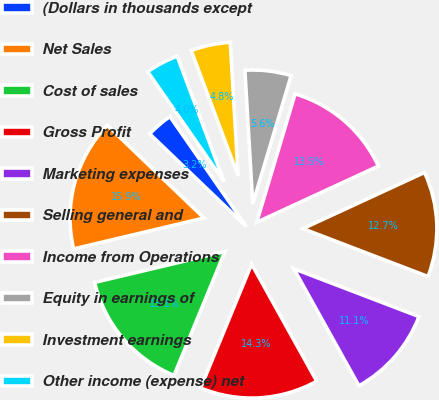<chart> <loc_0><loc_0><loc_500><loc_500><pie_chart><fcel>(Dollars in thousands except<fcel>Net Sales<fcel>Cost of sales<fcel>Gross Profit<fcel>Marketing expenses<fcel>Selling general and<fcel>Income from Operations<fcel>Equity in earnings of<fcel>Investment earnings<fcel>Other income (expense) net<nl><fcel>3.17%<fcel>15.87%<fcel>15.08%<fcel>14.29%<fcel>11.11%<fcel>12.7%<fcel>13.49%<fcel>5.56%<fcel>4.76%<fcel>3.97%<nl></chart> 